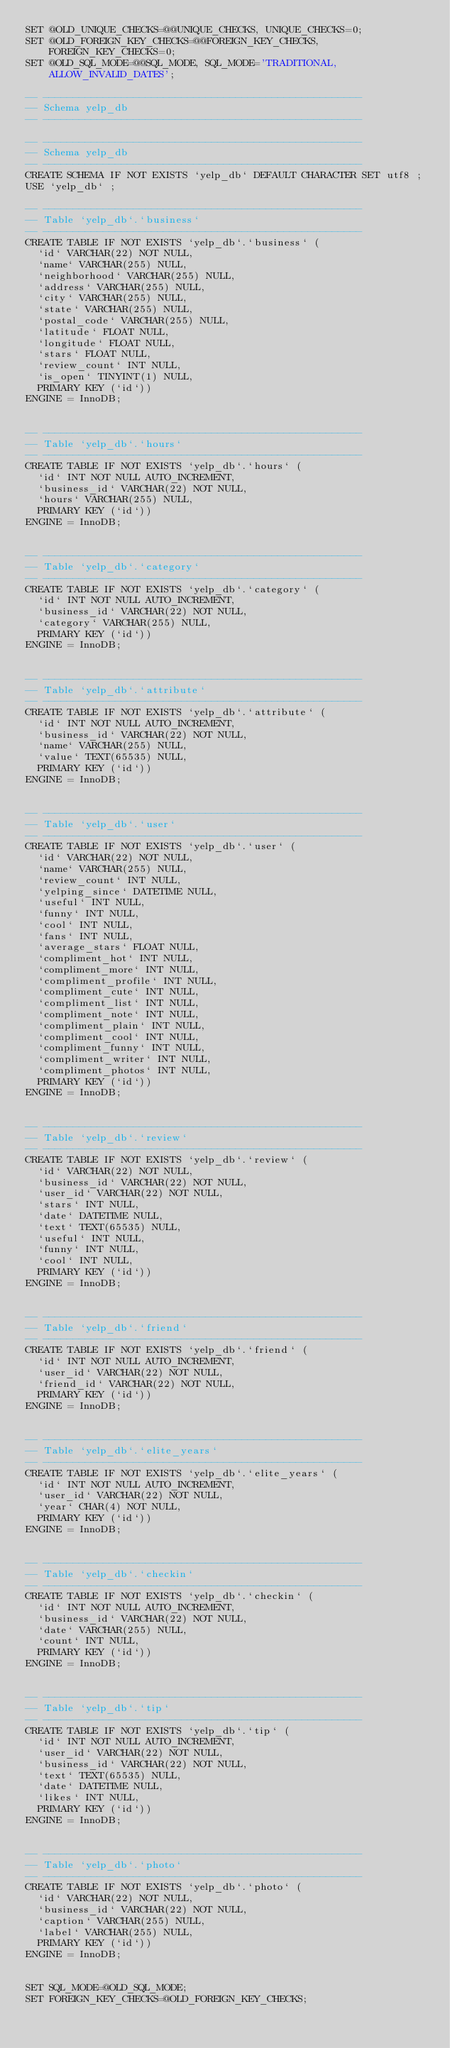<code> <loc_0><loc_0><loc_500><loc_500><_SQL_>SET @OLD_UNIQUE_CHECKS=@@UNIQUE_CHECKS, UNIQUE_CHECKS=0;
SET @OLD_FOREIGN_KEY_CHECKS=@@FOREIGN_KEY_CHECKS, FOREIGN_KEY_CHECKS=0;
SET @OLD_SQL_MODE=@@SQL_MODE, SQL_MODE='TRADITIONAL,ALLOW_INVALID_DATES';

-- -----------------------------------------------------
-- Schema yelp_db
-- -----------------------------------------------------

-- -----------------------------------------------------
-- Schema yelp_db
-- -----------------------------------------------------
CREATE SCHEMA IF NOT EXISTS `yelp_db` DEFAULT CHARACTER SET utf8 ;
USE `yelp_db` ;

-- -----------------------------------------------------
-- Table `yelp_db`.`business`
-- -----------------------------------------------------
CREATE TABLE IF NOT EXISTS `yelp_db`.`business` (
  `id` VARCHAR(22) NOT NULL,
  `name` VARCHAR(255) NULL,
  `neighborhood` VARCHAR(255) NULL,
  `address` VARCHAR(255) NULL,
  `city` VARCHAR(255) NULL,
  `state` VARCHAR(255) NULL,
  `postal_code` VARCHAR(255) NULL,
  `latitude` FLOAT NULL,
  `longitude` FLOAT NULL,
  `stars` FLOAT NULL,
  `review_count` INT NULL,
  `is_open` TINYINT(1) NULL,
  PRIMARY KEY (`id`))
ENGINE = InnoDB;


-- -----------------------------------------------------
-- Table `yelp_db`.`hours`
-- -----------------------------------------------------
CREATE TABLE IF NOT EXISTS `yelp_db`.`hours` (
  `id` INT NOT NULL AUTO_INCREMENT,
  `business_id` VARCHAR(22) NOT NULL,
  `hours` VARCHAR(255) NULL,
  PRIMARY KEY (`id`))
ENGINE = InnoDB;


-- -----------------------------------------------------
-- Table `yelp_db`.`category`
-- -----------------------------------------------------
CREATE TABLE IF NOT EXISTS `yelp_db`.`category` (
  `id` INT NOT NULL AUTO_INCREMENT,
  `business_id` VARCHAR(22) NOT NULL,
  `category` VARCHAR(255) NULL,
  PRIMARY KEY (`id`))
ENGINE = InnoDB;


-- -----------------------------------------------------
-- Table `yelp_db`.`attribute`
-- -----------------------------------------------------
CREATE TABLE IF NOT EXISTS `yelp_db`.`attribute` (
  `id` INT NOT NULL AUTO_INCREMENT,
  `business_id` VARCHAR(22) NOT NULL,
  `name` VARCHAR(255) NULL,
  `value` TEXT(65535) NULL,
  PRIMARY KEY (`id`))
ENGINE = InnoDB;


-- -----------------------------------------------------
-- Table `yelp_db`.`user`
-- -----------------------------------------------------
CREATE TABLE IF NOT EXISTS `yelp_db`.`user` (
  `id` VARCHAR(22) NOT NULL,
  `name` VARCHAR(255) NULL,
  `review_count` INT NULL,
  `yelping_since` DATETIME NULL,
  `useful` INT NULL,
  `funny` INT NULL,
  `cool` INT NULL,
  `fans` INT NULL,
  `average_stars` FLOAT NULL,
  `compliment_hot` INT NULL,
  `compliment_more` INT NULL,
  `compliment_profile` INT NULL,
  `compliment_cute` INT NULL,
  `compliment_list` INT NULL,
  `compliment_note` INT NULL,
  `compliment_plain` INT NULL,
  `compliment_cool` INT NULL,
  `compliment_funny` INT NULL,
  `compliment_writer` INT NULL,
  `compliment_photos` INT NULL,
  PRIMARY KEY (`id`))
ENGINE = InnoDB;


-- -----------------------------------------------------
-- Table `yelp_db`.`review`
-- -----------------------------------------------------
CREATE TABLE IF NOT EXISTS `yelp_db`.`review` (
  `id` VARCHAR(22) NOT NULL,
  `business_id` VARCHAR(22) NOT NULL,
  `user_id` VARCHAR(22) NOT NULL,
  `stars` INT NULL,
  `date` DATETIME NULL,
  `text` TEXT(65535) NULL,
  `useful` INT NULL,
  `funny` INT NULL,
  `cool` INT NULL,
  PRIMARY KEY (`id`))
ENGINE = InnoDB;


-- -----------------------------------------------------
-- Table `yelp_db`.`friend`
-- -----------------------------------------------------
CREATE TABLE IF NOT EXISTS `yelp_db`.`friend` (
  `id` INT NOT NULL AUTO_INCREMENT,
  `user_id` VARCHAR(22) NOT NULL,
  `friend_id` VARCHAR(22) NOT NULL,
  PRIMARY KEY (`id`))
ENGINE = InnoDB;


-- -----------------------------------------------------
-- Table `yelp_db`.`elite_years`
-- -----------------------------------------------------
CREATE TABLE IF NOT EXISTS `yelp_db`.`elite_years` (
  `id` INT NOT NULL AUTO_INCREMENT,
  `user_id` VARCHAR(22) NOT NULL,
  `year` CHAR(4) NOT NULL,
  PRIMARY KEY (`id`))
ENGINE = InnoDB;


-- -----------------------------------------------------
-- Table `yelp_db`.`checkin`
-- -----------------------------------------------------
CREATE TABLE IF NOT EXISTS `yelp_db`.`checkin` (
  `id` INT NOT NULL AUTO_INCREMENT,
  `business_id` VARCHAR(22) NOT NULL,
  `date` VARCHAR(255) NULL,
  `count` INT NULL,
  PRIMARY KEY (`id`))
ENGINE = InnoDB;


-- -----------------------------------------------------
-- Table `yelp_db`.`tip`
-- -----------------------------------------------------
CREATE TABLE IF NOT EXISTS `yelp_db`.`tip` (
  `id` INT NOT NULL AUTO_INCREMENT,
  `user_id` VARCHAR(22) NOT NULL,
  `business_id` VARCHAR(22) NOT NULL,
  `text` TEXT(65535) NULL,
  `date` DATETIME NULL,
  `likes` INT NULL,
  PRIMARY KEY (`id`))
ENGINE = InnoDB;


-- -----------------------------------------------------
-- Table `yelp_db`.`photo`
-- -----------------------------------------------------
CREATE TABLE IF NOT EXISTS `yelp_db`.`photo` (
  `id` VARCHAR(22) NOT NULL,
  `business_id` VARCHAR(22) NOT NULL,
  `caption` VARCHAR(255) NULL,
  `label` VARCHAR(255) NULL,
  PRIMARY KEY (`id`))
ENGINE = InnoDB;


SET SQL_MODE=@OLD_SQL_MODE;
SET FOREIGN_KEY_CHECKS=@OLD_FOREIGN_KEY_CHECKS;</code> 